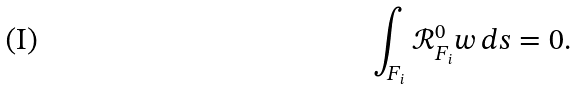<formula> <loc_0><loc_0><loc_500><loc_500>\int _ { F _ { i } } \mathcal { R } ^ { 0 } _ { F _ { i } } w \, d s = 0 .</formula> 